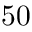Convert formula to latex. <formula><loc_0><loc_0><loc_500><loc_500>5 0</formula> 